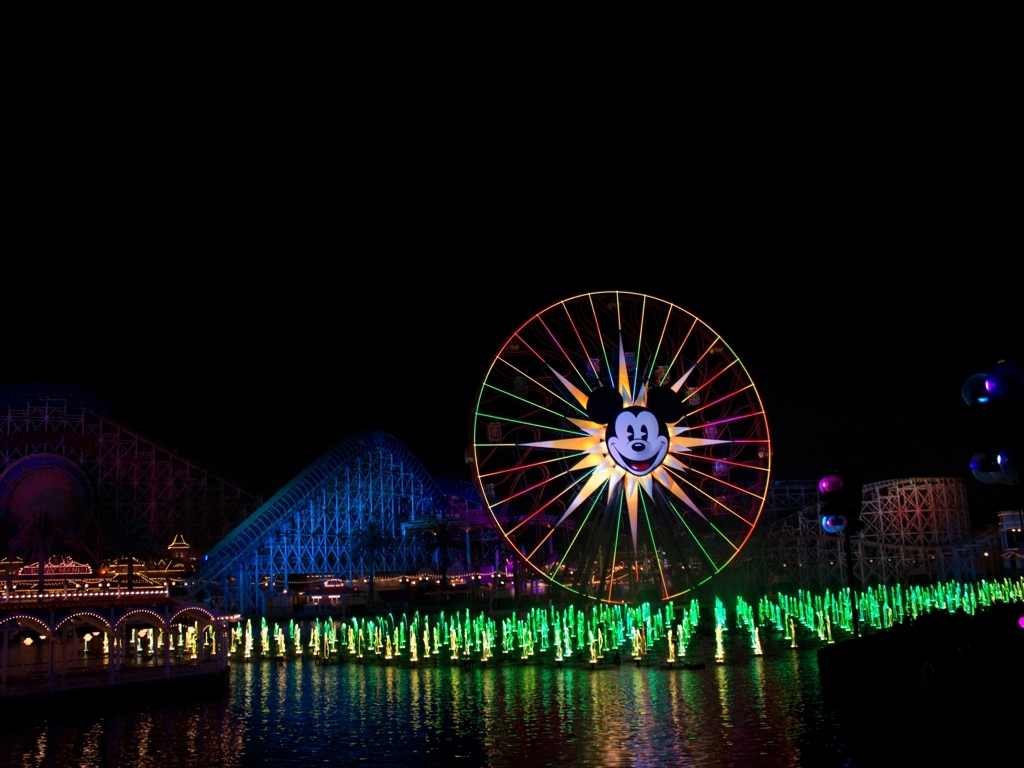What is the significance of the Ferris wheel in this image? The Ferris wheel, illuminated with a dynamic array of colors and featuring a character at its center, serves as an iconic centerpiece in this image. It symbolizes joy and childhood nostalgia, drawing the viewer's attention as a bright focal point against the night sky. Can you tell how the water interacts with light in this scene? The water in this scene acts as a mirror, reflecting the radiant lights from the Ferris wheel and fountain show. This interplay adds a magical element to the scene, as the ripples create fluctuating reflections that enhance the overall visual appeal. 